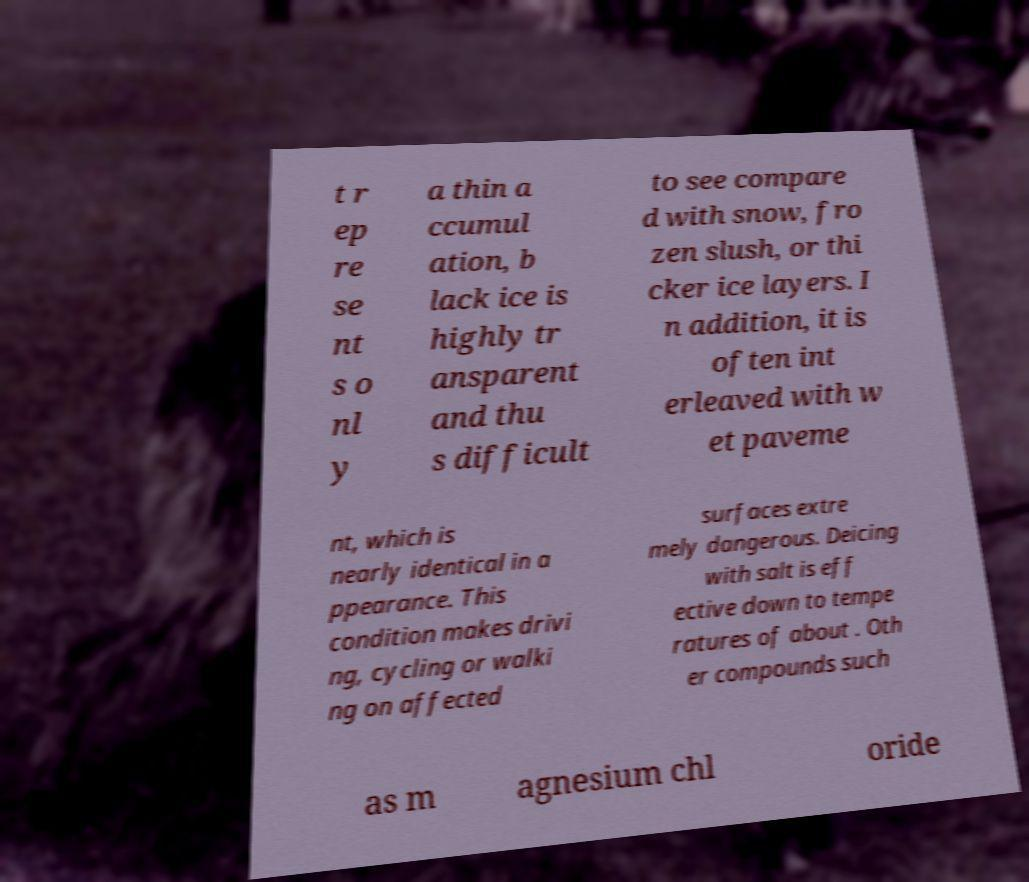Can you accurately transcribe the text from the provided image for me? t r ep re se nt s o nl y a thin a ccumul ation, b lack ice is highly tr ansparent and thu s difficult to see compare d with snow, fro zen slush, or thi cker ice layers. I n addition, it is often int erleaved with w et paveme nt, which is nearly identical in a ppearance. This condition makes drivi ng, cycling or walki ng on affected surfaces extre mely dangerous. Deicing with salt is eff ective down to tempe ratures of about . Oth er compounds such as m agnesium chl oride 